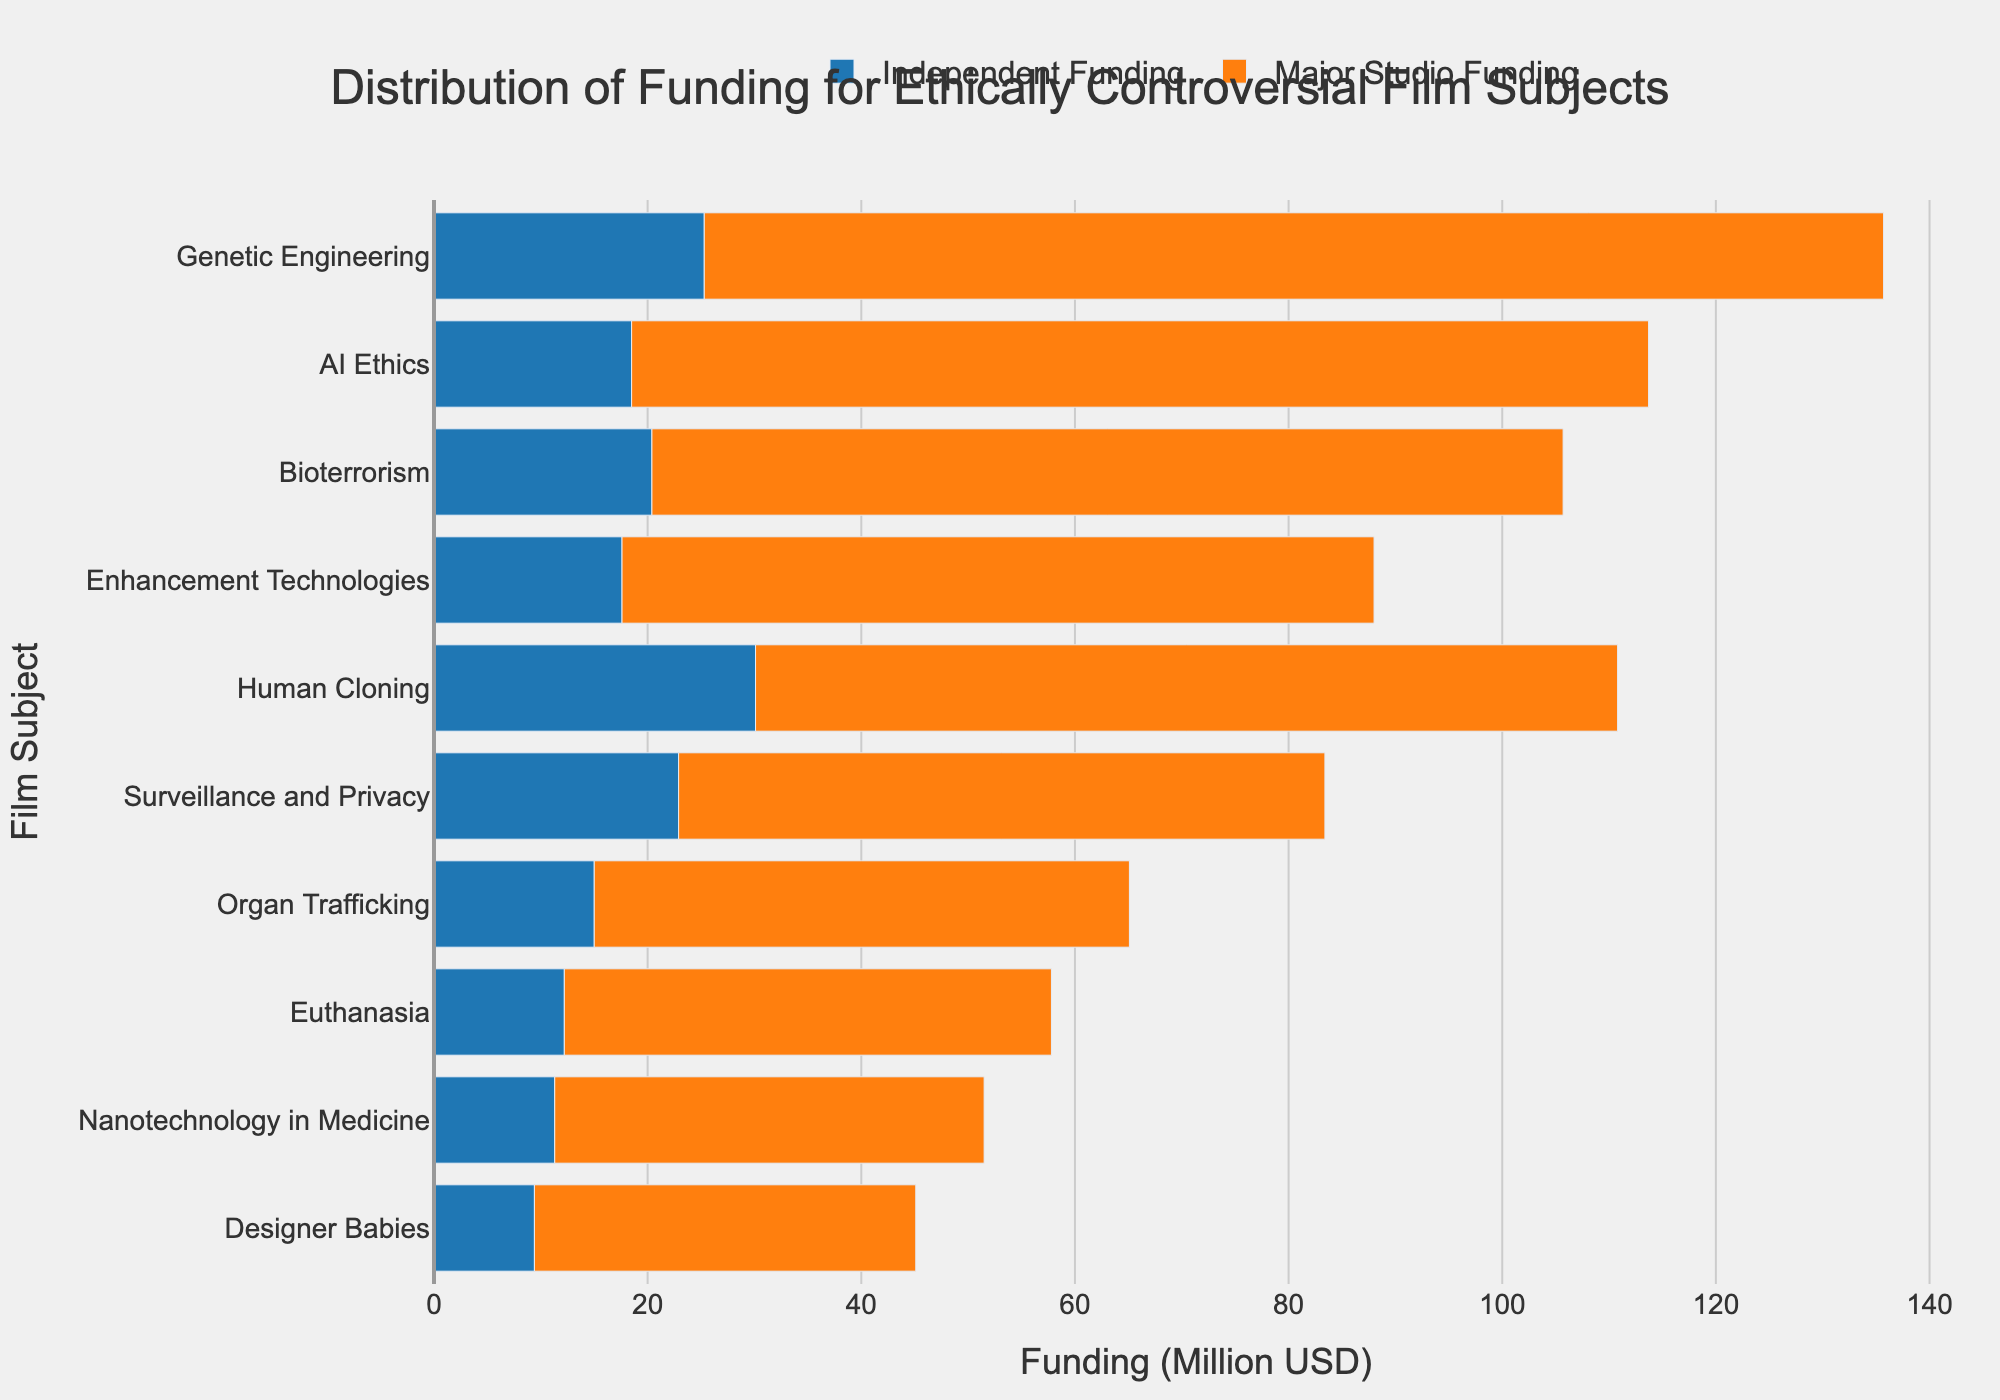What is the total funding for "Genetic Engineering" across Independent and Major Studio categories? To get the total funding for "Genetic Engineering," sum up the Independent Funding and Major Studio Funding. This is 25.3M + 110.4M = 135.7M
Answer: 135.7M Which film subject has the smallest difference in funding between Independent and Major Studios? By comparing the differences calculated for each subject, "Nanotechnology in Medicine" has the smallest difference: 40.2M - 11.3M = 28.9M
Answer: Nanotechnology in Medicine How much more funding does "Human Cloning" receive from Major Studios compared to Independent Studios? Subtract the Independent Funding from the Major Studio Funding for "Human Cloning": 80.7M - 30.1M = 50.6M
Answer: 50.6M What is the average independent funding for all film subjects? Sum up the Independent Funding for all subjects: 25.3 + 18.5 + 12.2 + 30.1 + 22.9 + 15.0 + 20.4 + 17.6 + 11.3 + 9.4 = 182.7M. Then, divide by the number of subjects (10): 182.7 / 10 = 18.27M
Answer: 18.27M Which film subject has the highest funding from Major Studios? Observing the lengths of the bars representing Major Studio Funding, "Genetic Engineering" has the highest bar at 110.4M
Answer: Genetic Engineering Does "Designer Babies" have more or less funding from Major Studios compared to Independent Studios? Compare the Major Studio Funding (35.7M) to the Independent Funding (9.4M) for "Designer Babies". Major Studio Funding is greater.
Answer: More What is the total of all Major Studio funding depicted in the chart? Sum up all Major Studio Funding values: 110.4 + 95.2 + 45.6 + 80.7 + 60.5 + 50.1 + 85.3 + 70.4 + 40.2 + 35.7 = 674.1M
Answer: 674.1M Which film subject saw the largest discrepancy in funding between Independent and Major Studios? By checking the differences for all film subjects, "AI Ethics" has the largest difference: 95.2M - 18.5M = 76.7M
Answer: AI Ethics What color represents Independent Funding in the chart? By examining the visual attributes, Independent Funding is represented by the blue bars.
Answer: Blue 